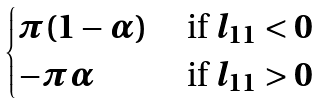Convert formula to latex. <formula><loc_0><loc_0><loc_500><loc_500>\begin{cases} \pi ( 1 - \alpha ) & \text { if } l _ { 1 1 } < 0 \\ - \pi \alpha & \text { if } l _ { 1 1 } > 0 \end{cases}</formula> 